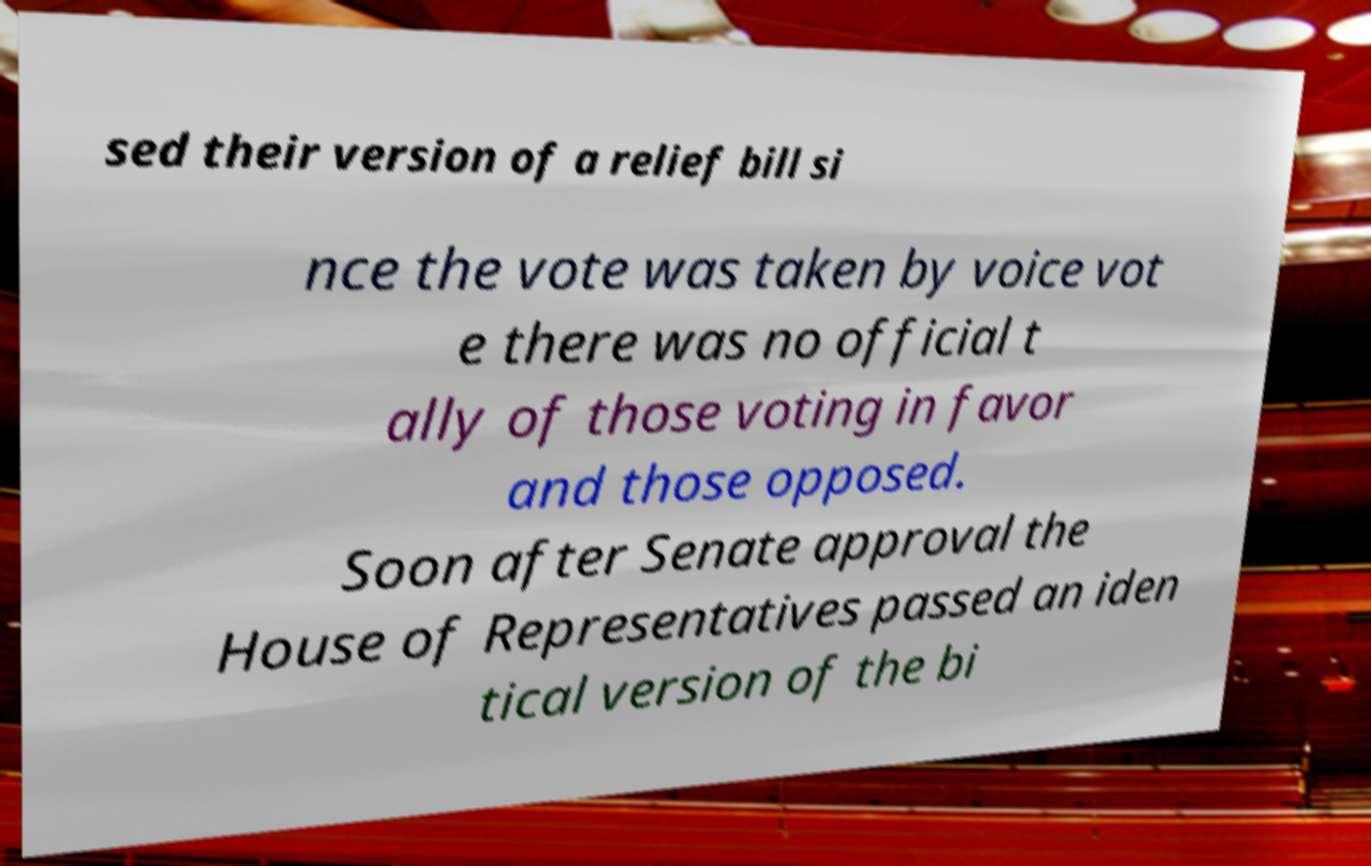Could you extract and type out the text from this image? sed their version of a relief bill si nce the vote was taken by voice vot e there was no official t ally of those voting in favor and those opposed. Soon after Senate approval the House of Representatives passed an iden tical version of the bi 